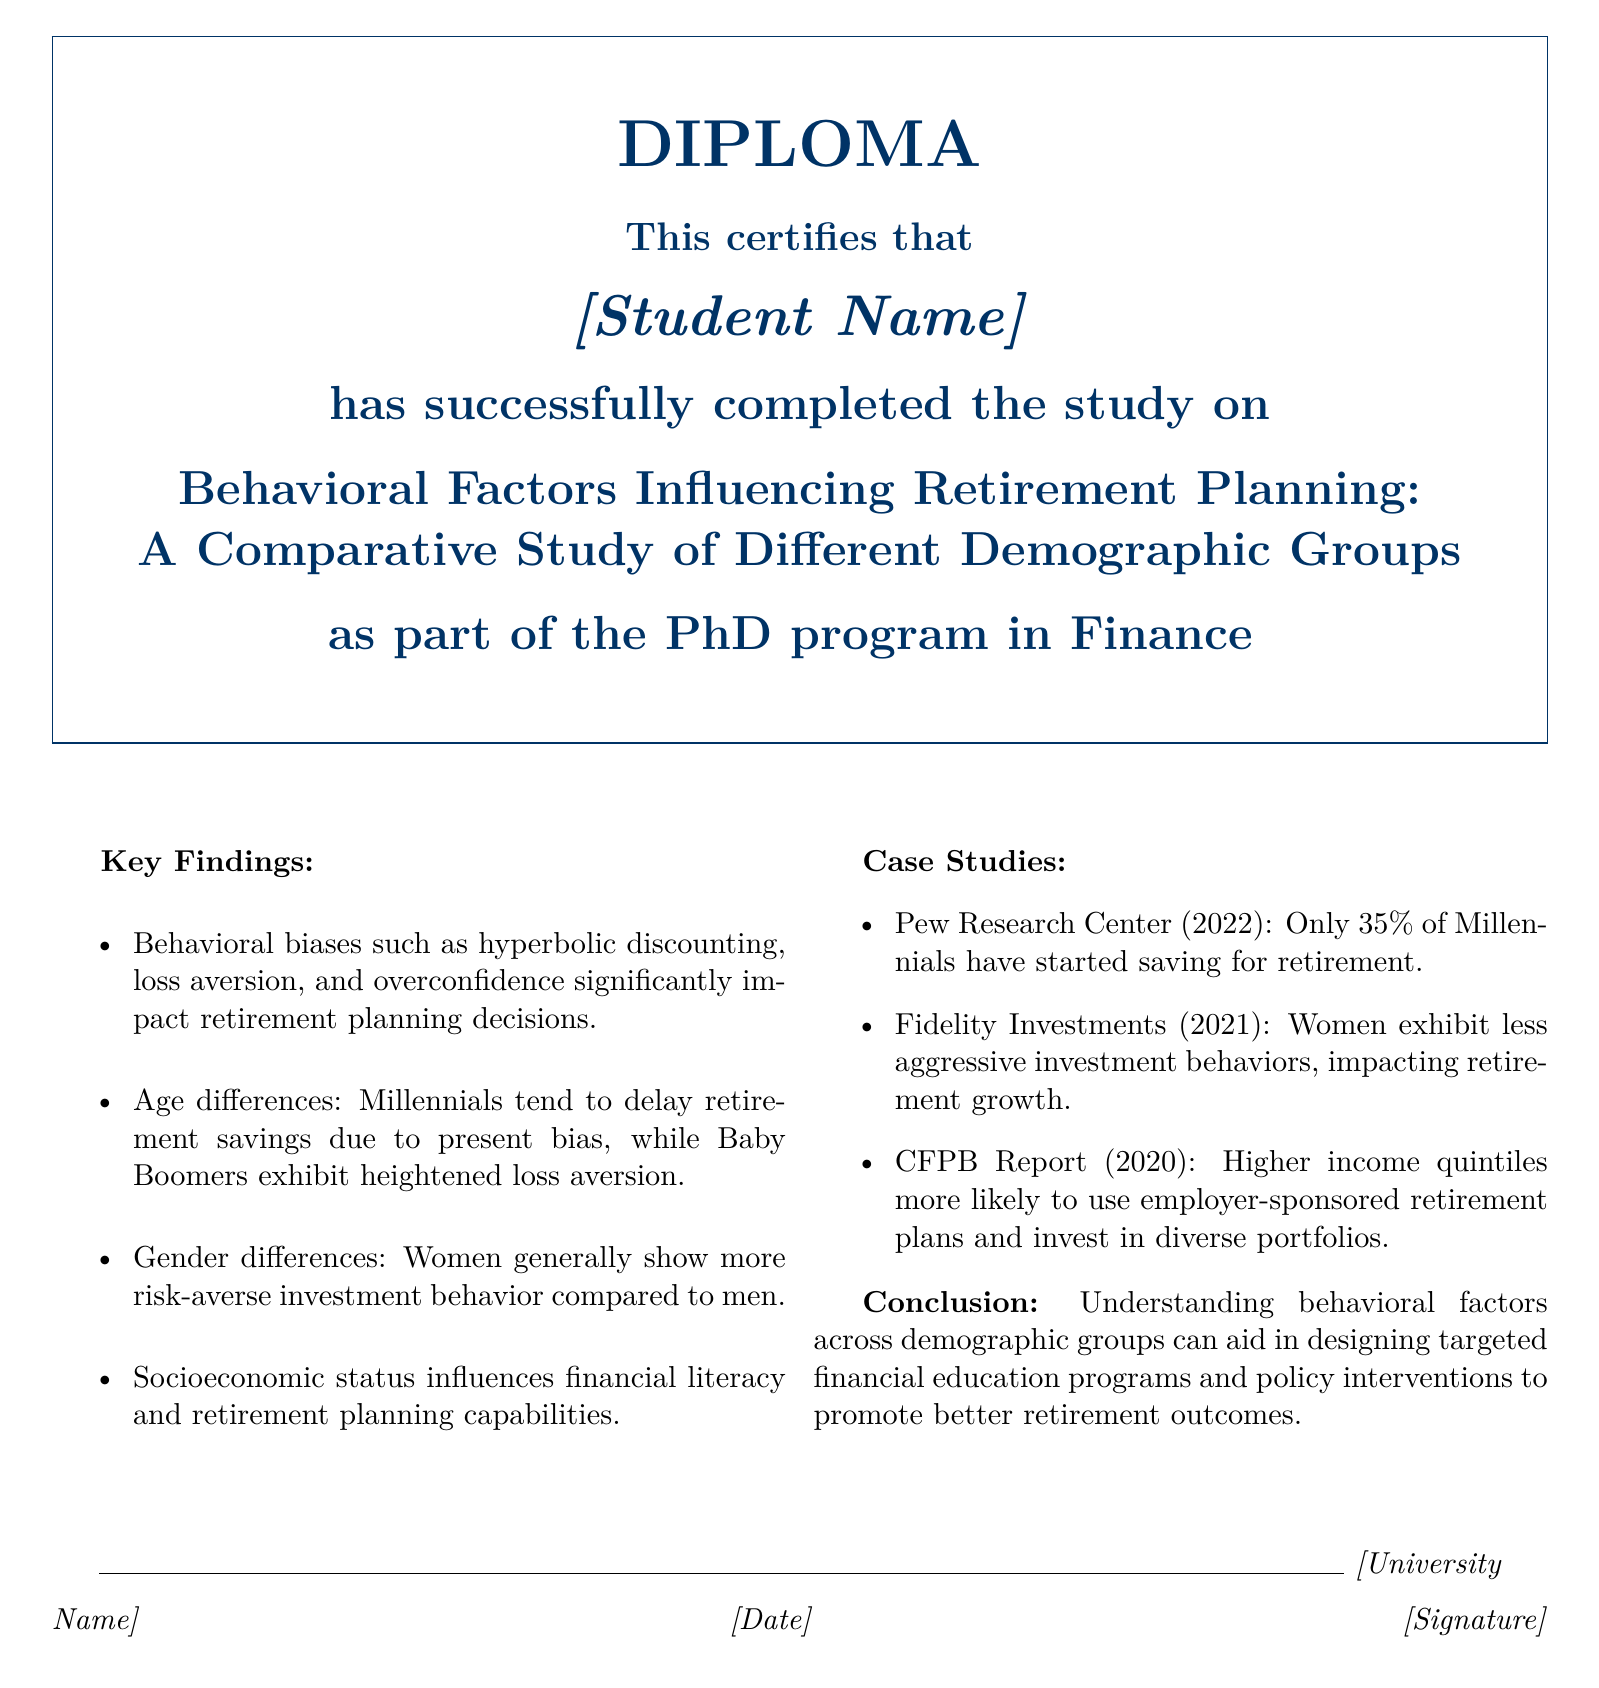what is the title of the study? The title of the study is presented at the top of the document, which is "Behavioral Factors Influencing Retirement Planning: A Comparative Study of Different Demographic Groups."
Answer: Behavioral Factors Influencing Retirement Planning: A Comparative Study of Different Demographic Groups who completed the study? The document specifies that the study was completed by "[Student Name]," a placeholder for the actual student's name.
Answer: [Student Name] what percentage of Millennials have started saving for retirement according to the Pew Research Center? The document cites a statistic from Pew Research Center stating that only 35% of Millennials have started saving for retirement.
Answer: 35% which demographic group shows heightened loss aversion? The document indicates that Baby Boomers exhibit heightened loss aversion in their retirement planning decisions.
Answer: Baby Boomers how does gender influence investment behavior according to the findings? The document outlines that women generally show more risk-averse investment behavior compared to men.
Answer: More risk-averse what is the role of socioeconomic status in retirement planning? The document states that socioeconomic status influences financial literacy and retirement planning capabilities.
Answer: Financial literacy and planning capabilities what is the conclusion of the study? The study concludes that understanding behavioral factors across demographic groups can help in designing targeted financial education programs and policy interventions.
Answer: Targeted financial education programs and policy interventions when was the CFPB Report released? The document states that the CFPB Report was released in 2020.
Answer: 2020 